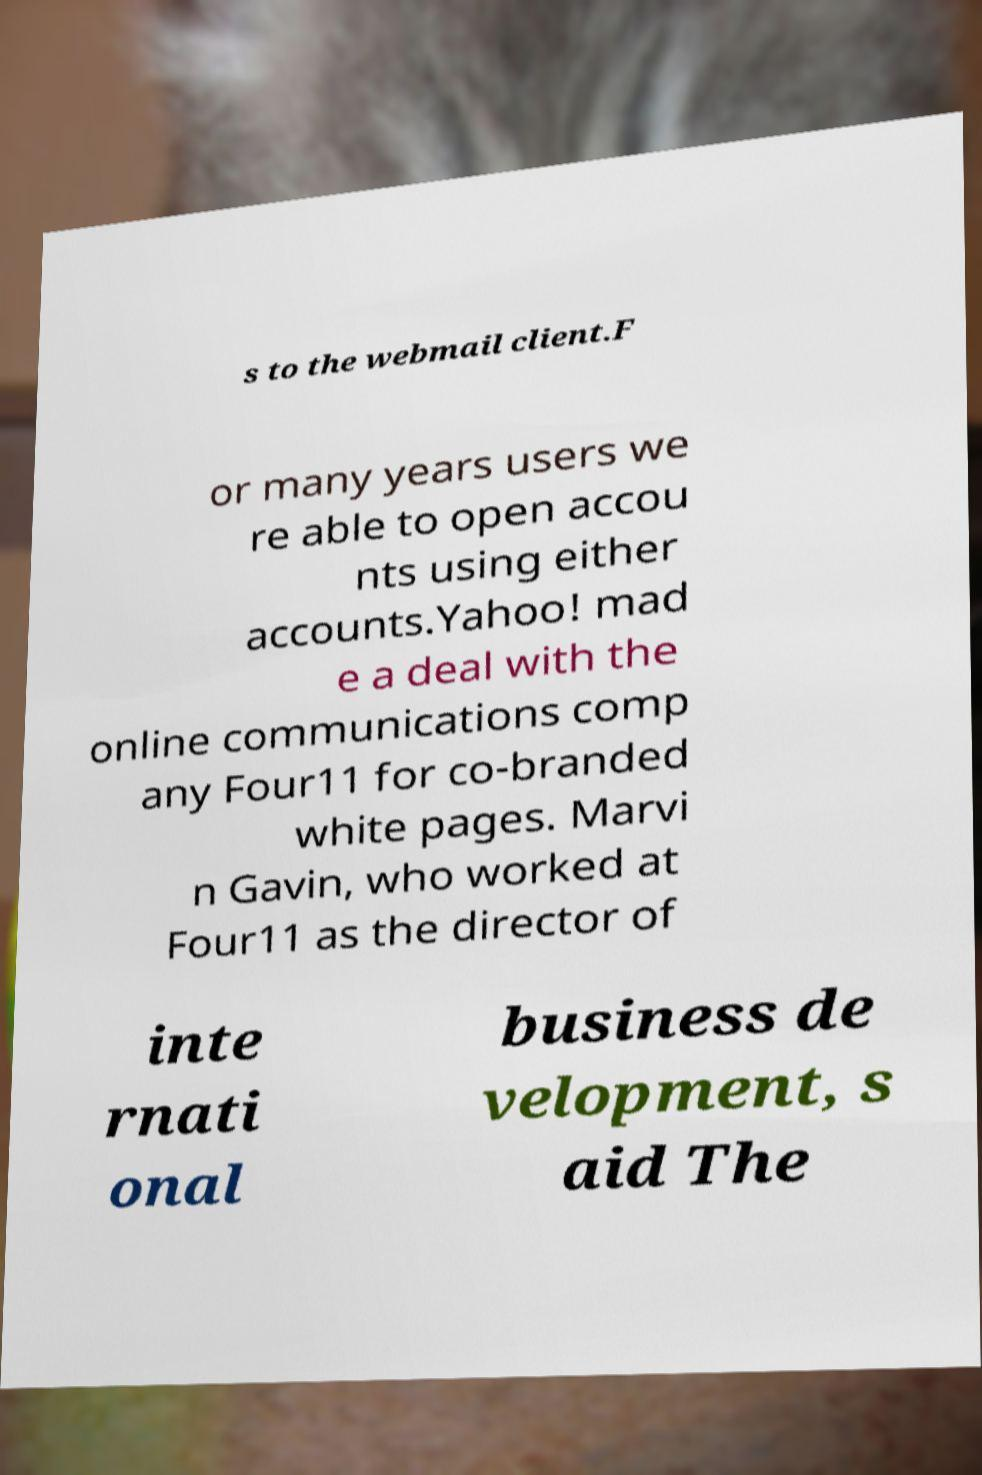For documentation purposes, I need the text within this image transcribed. Could you provide that? s to the webmail client.F or many years users we re able to open accou nts using either accounts.Yahoo! mad e a deal with the online communications comp any Four11 for co-branded white pages. Marvi n Gavin, who worked at Four11 as the director of inte rnati onal business de velopment, s aid The 